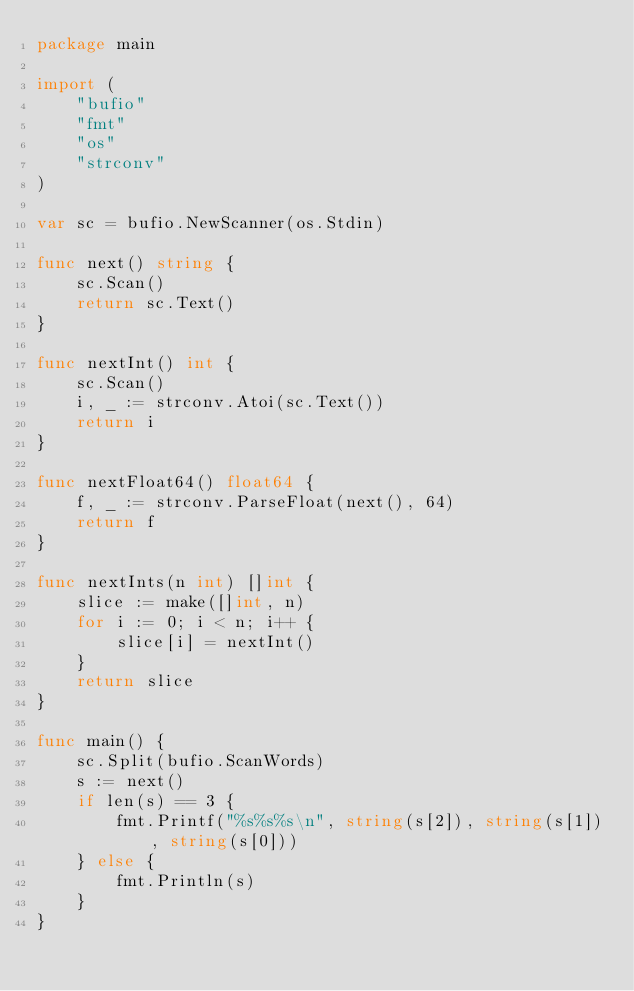Convert code to text. <code><loc_0><loc_0><loc_500><loc_500><_Go_>package main

import (
	"bufio"
	"fmt"
	"os"
	"strconv"
)

var sc = bufio.NewScanner(os.Stdin)

func next() string {
	sc.Scan()
	return sc.Text()
}

func nextInt() int {
	sc.Scan()
	i, _ := strconv.Atoi(sc.Text())
	return i
}

func nextFloat64() float64 {
	f, _ := strconv.ParseFloat(next(), 64)
	return f
}

func nextInts(n int) []int {
	slice := make([]int, n)
	for i := 0; i < n; i++ {
		slice[i] = nextInt()
	}
	return slice
}

func main() {
	sc.Split(bufio.ScanWords)
	s := next()
	if len(s) == 3 {
		fmt.Printf("%s%s%s\n", string(s[2]), string(s[1]), string(s[0]))
	} else {
		fmt.Println(s)
	}
}
</code> 